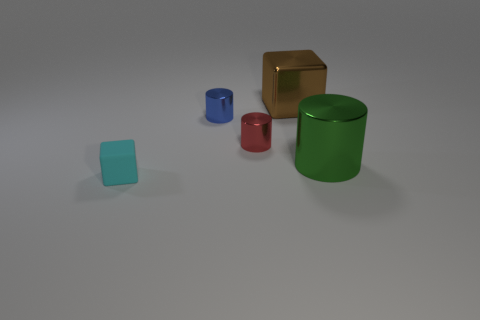Subtract all small blue shiny cylinders. How many cylinders are left? 2 Add 4 big gray matte cubes. How many objects exist? 9 Subtract all red cylinders. How many cylinders are left? 2 Subtract all blue blocks. How many green cylinders are left? 1 Subtract all red blocks. Subtract all purple balls. How many blocks are left? 2 Subtract all cylinders. How many objects are left? 2 Subtract 2 cylinders. How many cylinders are left? 1 Subtract all tiny blocks. Subtract all tiny blue cylinders. How many objects are left? 3 Add 4 red things. How many red things are left? 5 Add 3 red shiny cylinders. How many red shiny cylinders exist? 4 